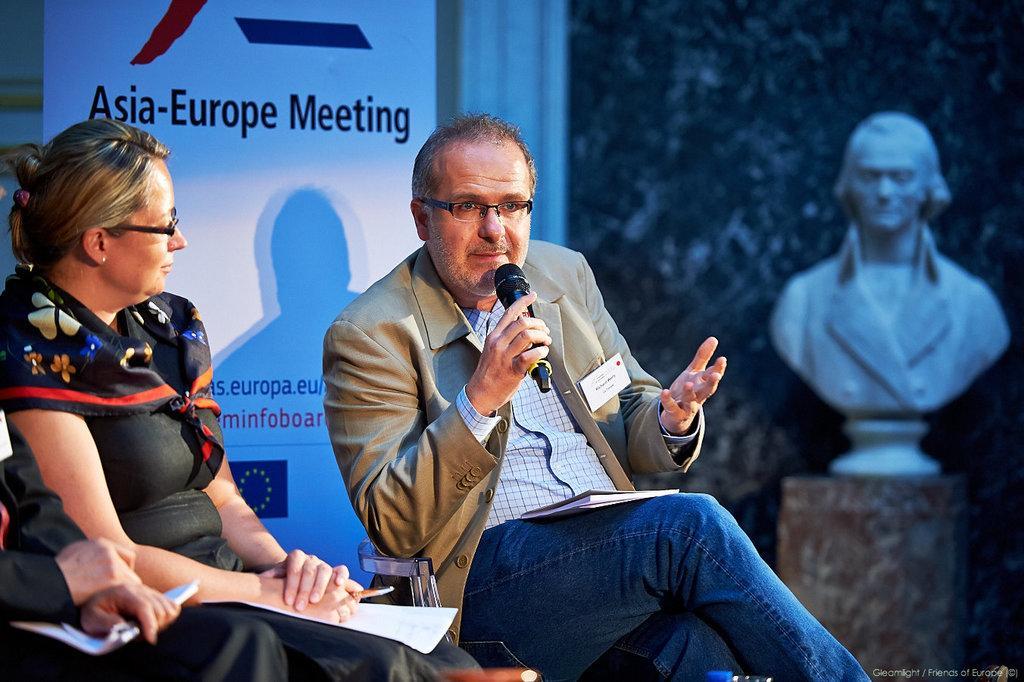Could you give a brief overview of what you see in this image? In this image I can see a man and a woman are sitting. The man is holding a microphone in the hand. Here I can see a board which has something written on it. I can also see a statue of a man. 